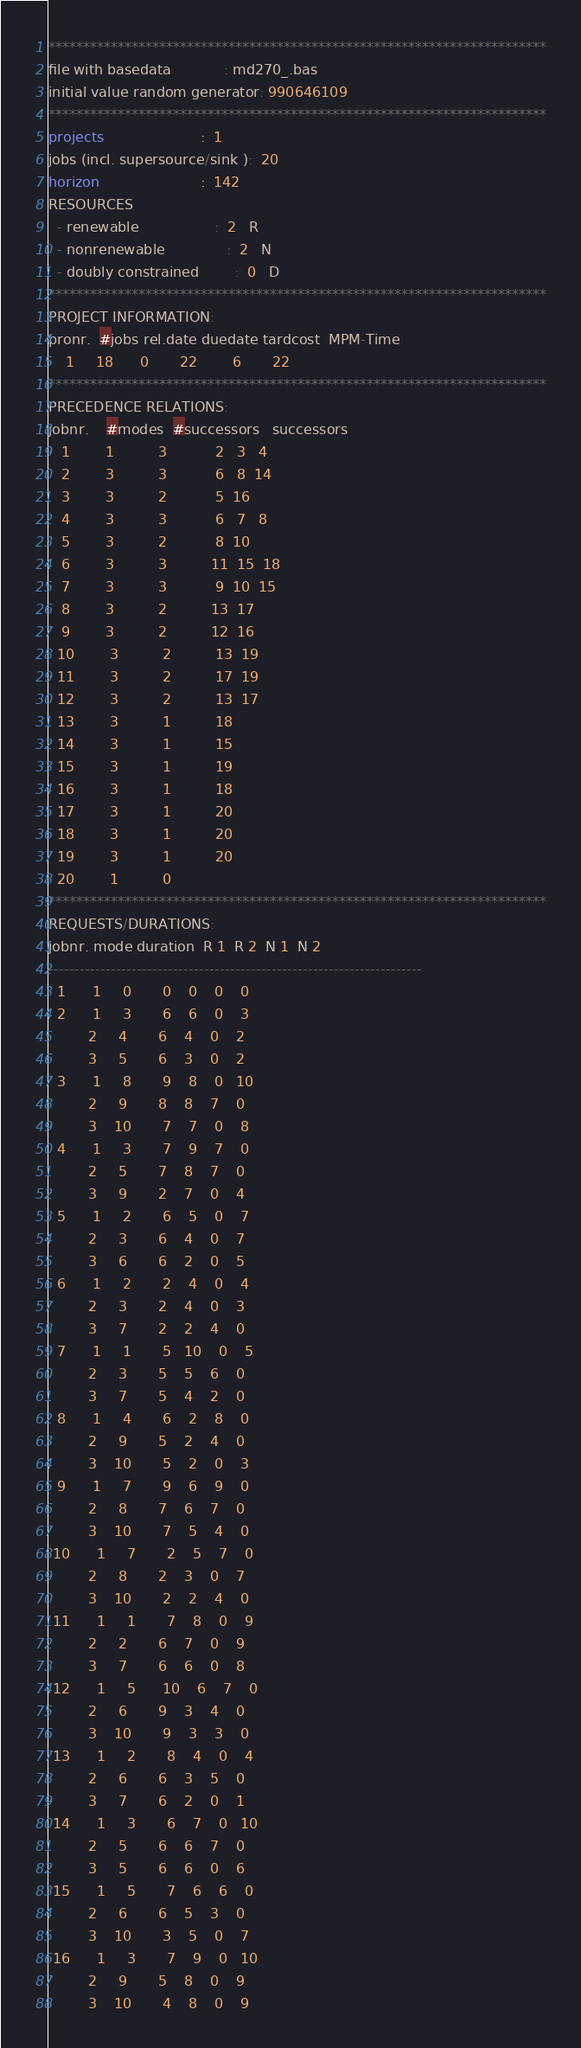Convert code to text. <code><loc_0><loc_0><loc_500><loc_500><_ObjectiveC_>************************************************************************
file with basedata            : md270_.bas
initial value random generator: 990646109
************************************************************************
projects                      :  1
jobs (incl. supersource/sink ):  20
horizon                       :  142
RESOURCES
  - renewable                 :  2   R
  - nonrenewable              :  2   N
  - doubly constrained        :  0   D
************************************************************************
PROJECT INFORMATION:
pronr.  #jobs rel.date duedate tardcost  MPM-Time
    1     18      0       22        6       22
************************************************************************
PRECEDENCE RELATIONS:
jobnr.    #modes  #successors   successors
   1        1          3           2   3   4
   2        3          3           6   8  14
   3        3          2           5  16
   4        3          3           6   7   8
   5        3          2           8  10
   6        3          3          11  15  18
   7        3          3           9  10  15
   8        3          2          13  17
   9        3          2          12  16
  10        3          2          13  19
  11        3          2          17  19
  12        3          2          13  17
  13        3          1          18
  14        3          1          15
  15        3          1          19
  16        3          1          18
  17        3          1          20
  18        3          1          20
  19        3          1          20
  20        1          0        
************************************************************************
REQUESTS/DURATIONS:
jobnr. mode duration  R 1  R 2  N 1  N 2
------------------------------------------------------------------------
  1      1     0       0    0    0    0
  2      1     3       6    6    0    3
         2     4       6    4    0    2
         3     5       6    3    0    2
  3      1     8       9    8    0   10
         2     9       8    8    7    0
         3    10       7    7    0    8
  4      1     3       7    9    7    0
         2     5       7    8    7    0
         3     9       2    7    0    4
  5      1     2       6    5    0    7
         2     3       6    4    0    7
         3     6       6    2    0    5
  6      1     2       2    4    0    4
         2     3       2    4    0    3
         3     7       2    2    4    0
  7      1     1       5   10    0    5
         2     3       5    5    6    0
         3     7       5    4    2    0
  8      1     4       6    2    8    0
         2     9       5    2    4    0
         3    10       5    2    0    3
  9      1     7       9    6    9    0
         2     8       7    6    7    0
         3    10       7    5    4    0
 10      1     7       2    5    7    0
         2     8       2    3    0    7
         3    10       2    2    4    0
 11      1     1       7    8    0    9
         2     2       6    7    0    9
         3     7       6    6    0    8
 12      1     5      10    6    7    0
         2     6       9    3    4    0
         3    10       9    3    3    0
 13      1     2       8    4    0    4
         2     6       6    3    5    0
         3     7       6    2    0    1
 14      1     3       6    7    0   10
         2     5       6    6    7    0
         3     5       6    6    0    6
 15      1     5       7    6    6    0
         2     6       6    5    3    0
         3    10       3    5    0    7
 16      1     3       7    9    0   10
         2     9       5    8    0    9
         3    10       4    8    0    9</code> 